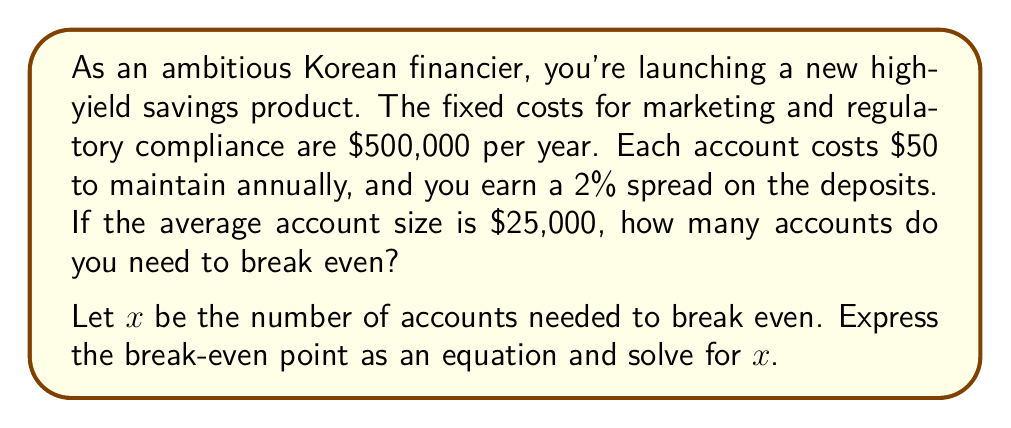Give your solution to this math problem. To solve this problem, we need to set up the break-even equation where total revenue equals total costs.

1. Fixed costs: $500,000 per year
2. Variable costs: $50 per account per year
3. Revenue: 2% spread on $25,000 average account size = $500 per account per year

Let's set up the equation:

Total Revenue = Total Costs
$500x = 500,000 + 50x$

Now, let's solve for $x$:

$$\begin{align}
500x &= 500,000 + 50x \\
500x - 50x &= 500,000 \\
450x &= 500,000 \\
x &= \frac{500,000}{450} \\
x &= 1,111.11
\end{align}$$

Since we can't have a fractional number of accounts, we need to round up to the nearest whole number.
Answer: The break-even point is 1,112 accounts. 